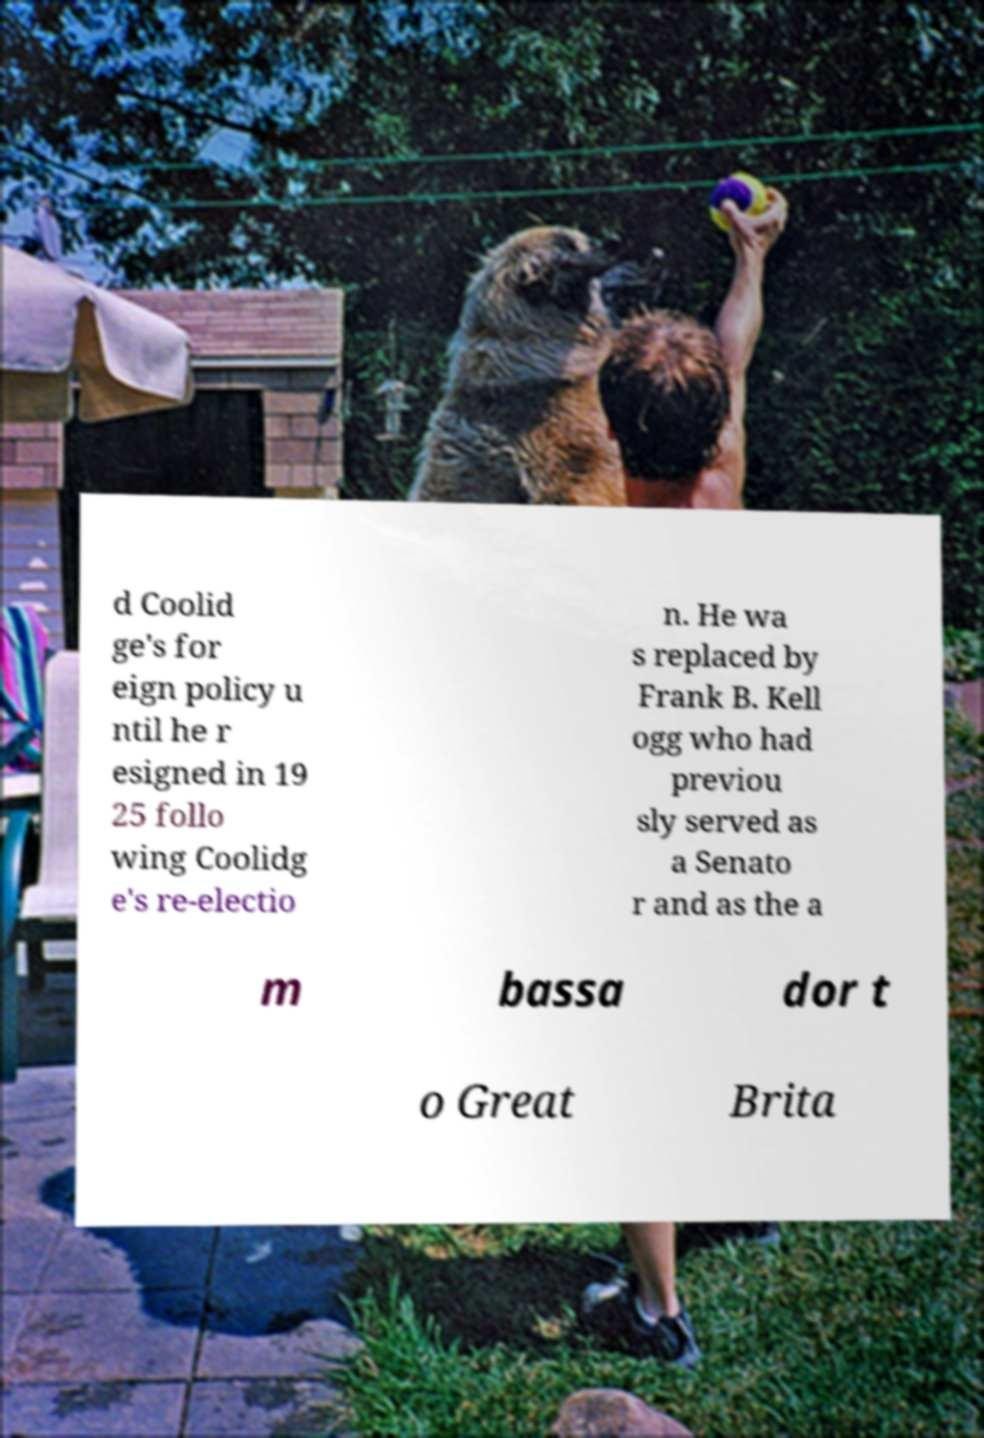There's text embedded in this image that I need extracted. Can you transcribe it verbatim? d Coolid ge's for eign policy u ntil he r esigned in 19 25 follo wing Coolidg e's re-electio n. He wa s replaced by Frank B. Kell ogg who had previou sly served as a Senato r and as the a m bassa dor t o Great Brita 